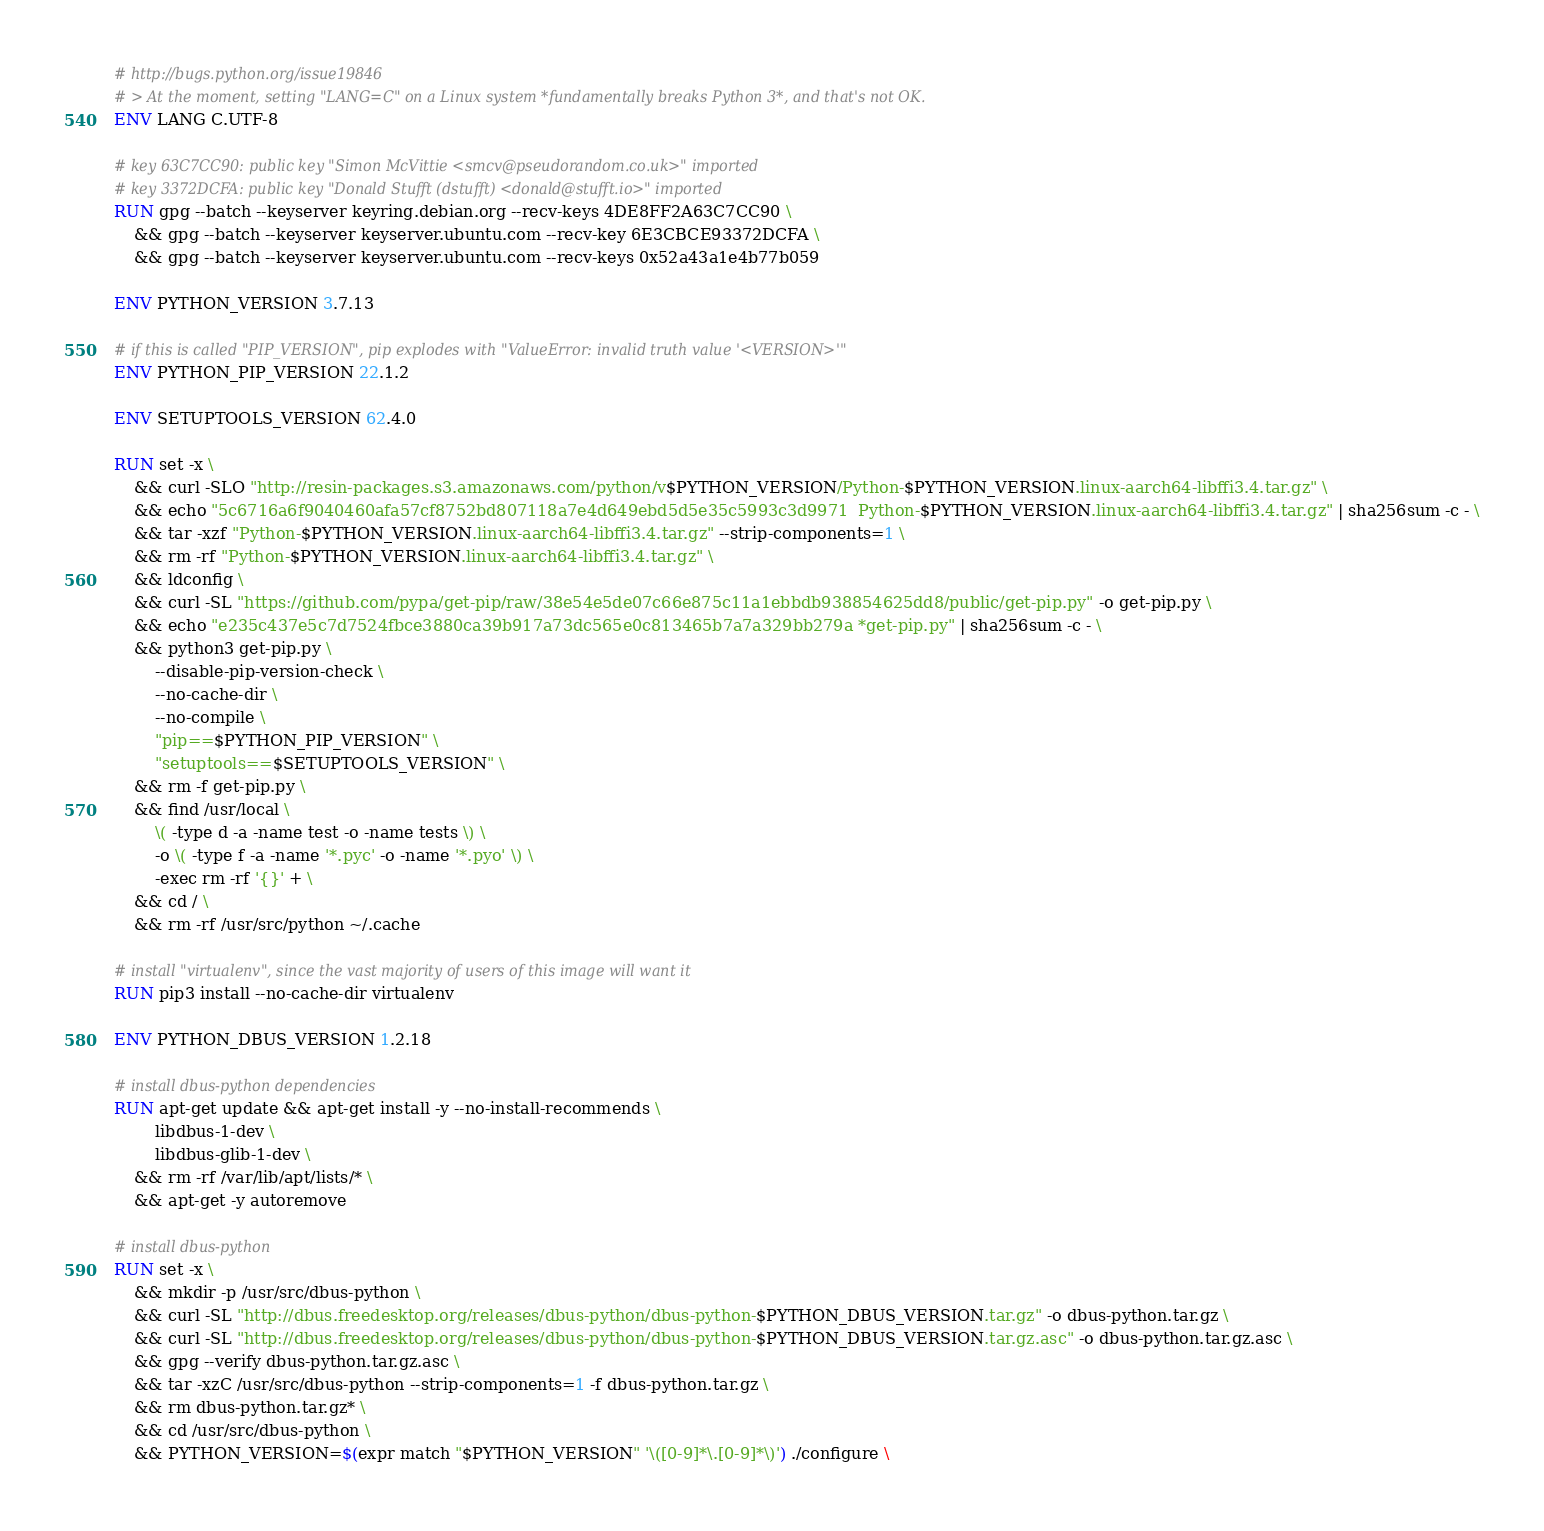Convert code to text. <code><loc_0><loc_0><loc_500><loc_500><_Dockerfile_>
# http://bugs.python.org/issue19846
# > At the moment, setting "LANG=C" on a Linux system *fundamentally breaks Python 3*, and that's not OK.
ENV LANG C.UTF-8

# key 63C7CC90: public key "Simon McVittie <smcv@pseudorandom.co.uk>" imported
# key 3372DCFA: public key "Donald Stufft (dstufft) <donald@stufft.io>" imported
RUN gpg --batch --keyserver keyring.debian.org --recv-keys 4DE8FF2A63C7CC90 \
    && gpg --batch --keyserver keyserver.ubuntu.com --recv-key 6E3CBCE93372DCFA \
    && gpg --batch --keyserver keyserver.ubuntu.com --recv-keys 0x52a43a1e4b77b059

ENV PYTHON_VERSION 3.7.13

# if this is called "PIP_VERSION", pip explodes with "ValueError: invalid truth value '<VERSION>'"
ENV PYTHON_PIP_VERSION 22.1.2

ENV SETUPTOOLS_VERSION 62.4.0

RUN set -x \
    && curl -SLO "http://resin-packages.s3.amazonaws.com/python/v$PYTHON_VERSION/Python-$PYTHON_VERSION.linux-aarch64-libffi3.4.tar.gz" \
    && echo "5c6716a6f9040460afa57cf8752bd807118a7e4d649ebd5d5e35c5993c3d9971  Python-$PYTHON_VERSION.linux-aarch64-libffi3.4.tar.gz" | sha256sum -c - \
    && tar -xzf "Python-$PYTHON_VERSION.linux-aarch64-libffi3.4.tar.gz" --strip-components=1 \
    && rm -rf "Python-$PYTHON_VERSION.linux-aarch64-libffi3.4.tar.gz" \
    && ldconfig \
    && curl -SL "https://github.com/pypa/get-pip/raw/38e54e5de07c66e875c11a1ebbdb938854625dd8/public/get-pip.py" -o get-pip.py \
    && echo "e235c437e5c7d7524fbce3880ca39b917a73dc565e0c813465b7a7a329bb279a *get-pip.py" | sha256sum -c - \
    && python3 get-pip.py \
        --disable-pip-version-check \
        --no-cache-dir \
        --no-compile \
        "pip==$PYTHON_PIP_VERSION" \
        "setuptools==$SETUPTOOLS_VERSION" \
    && rm -f get-pip.py \
    && find /usr/local \
        \( -type d -a -name test -o -name tests \) \
        -o \( -type f -a -name '*.pyc' -o -name '*.pyo' \) \
        -exec rm -rf '{}' + \
    && cd / \
    && rm -rf /usr/src/python ~/.cache

# install "virtualenv", since the vast majority of users of this image will want it
RUN pip3 install --no-cache-dir virtualenv

ENV PYTHON_DBUS_VERSION 1.2.18

# install dbus-python dependencies 
RUN apt-get update && apt-get install -y --no-install-recommends \
		libdbus-1-dev \
		libdbus-glib-1-dev \
	&& rm -rf /var/lib/apt/lists/* \
	&& apt-get -y autoremove

# install dbus-python
RUN set -x \
	&& mkdir -p /usr/src/dbus-python \
	&& curl -SL "http://dbus.freedesktop.org/releases/dbus-python/dbus-python-$PYTHON_DBUS_VERSION.tar.gz" -o dbus-python.tar.gz \
	&& curl -SL "http://dbus.freedesktop.org/releases/dbus-python/dbus-python-$PYTHON_DBUS_VERSION.tar.gz.asc" -o dbus-python.tar.gz.asc \
	&& gpg --verify dbus-python.tar.gz.asc \
	&& tar -xzC /usr/src/dbus-python --strip-components=1 -f dbus-python.tar.gz \
	&& rm dbus-python.tar.gz* \
	&& cd /usr/src/dbus-python \
	&& PYTHON_VERSION=$(expr match "$PYTHON_VERSION" '\([0-9]*\.[0-9]*\)') ./configure \</code> 